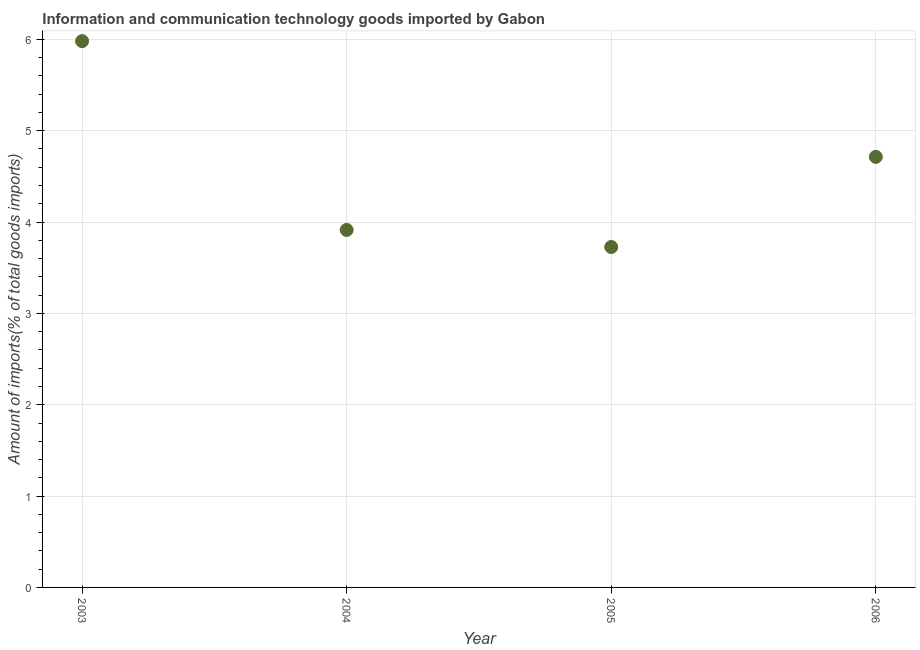What is the amount of ict goods imports in 2004?
Offer a terse response. 3.91. Across all years, what is the maximum amount of ict goods imports?
Ensure brevity in your answer.  5.98. Across all years, what is the minimum amount of ict goods imports?
Offer a very short reply. 3.73. In which year was the amount of ict goods imports maximum?
Provide a short and direct response. 2003. What is the sum of the amount of ict goods imports?
Provide a succinct answer. 18.34. What is the difference between the amount of ict goods imports in 2004 and 2005?
Your answer should be very brief. 0.19. What is the average amount of ict goods imports per year?
Your response must be concise. 4.58. What is the median amount of ict goods imports?
Give a very brief answer. 4.31. Do a majority of the years between 2006 and 2003 (inclusive) have amount of ict goods imports greater than 2.2 %?
Your answer should be very brief. Yes. What is the ratio of the amount of ict goods imports in 2004 to that in 2005?
Offer a terse response. 1.05. What is the difference between the highest and the second highest amount of ict goods imports?
Keep it short and to the point. 1.27. Is the sum of the amount of ict goods imports in 2004 and 2005 greater than the maximum amount of ict goods imports across all years?
Offer a terse response. Yes. What is the difference between the highest and the lowest amount of ict goods imports?
Offer a terse response. 2.25. What is the difference between two consecutive major ticks on the Y-axis?
Provide a succinct answer. 1. What is the title of the graph?
Your response must be concise. Information and communication technology goods imported by Gabon. What is the label or title of the Y-axis?
Offer a very short reply. Amount of imports(% of total goods imports). What is the Amount of imports(% of total goods imports) in 2003?
Keep it short and to the point. 5.98. What is the Amount of imports(% of total goods imports) in 2004?
Offer a very short reply. 3.91. What is the Amount of imports(% of total goods imports) in 2005?
Your response must be concise. 3.73. What is the Amount of imports(% of total goods imports) in 2006?
Your answer should be compact. 4.71. What is the difference between the Amount of imports(% of total goods imports) in 2003 and 2004?
Make the answer very short. 2.07. What is the difference between the Amount of imports(% of total goods imports) in 2003 and 2005?
Give a very brief answer. 2.25. What is the difference between the Amount of imports(% of total goods imports) in 2003 and 2006?
Make the answer very short. 1.27. What is the difference between the Amount of imports(% of total goods imports) in 2004 and 2005?
Give a very brief answer. 0.19. What is the difference between the Amount of imports(% of total goods imports) in 2004 and 2006?
Your answer should be very brief. -0.8. What is the difference between the Amount of imports(% of total goods imports) in 2005 and 2006?
Your answer should be compact. -0.99. What is the ratio of the Amount of imports(% of total goods imports) in 2003 to that in 2004?
Your answer should be very brief. 1.53. What is the ratio of the Amount of imports(% of total goods imports) in 2003 to that in 2005?
Your answer should be compact. 1.6. What is the ratio of the Amount of imports(% of total goods imports) in 2003 to that in 2006?
Ensure brevity in your answer.  1.27. What is the ratio of the Amount of imports(% of total goods imports) in 2004 to that in 2005?
Your answer should be compact. 1.05. What is the ratio of the Amount of imports(% of total goods imports) in 2004 to that in 2006?
Ensure brevity in your answer.  0.83. What is the ratio of the Amount of imports(% of total goods imports) in 2005 to that in 2006?
Your response must be concise. 0.79. 